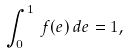Convert formula to latex. <formula><loc_0><loc_0><loc_500><loc_500>\int _ { 0 } ^ { 1 } \, f ( e ) \, d e = 1 ,</formula> 